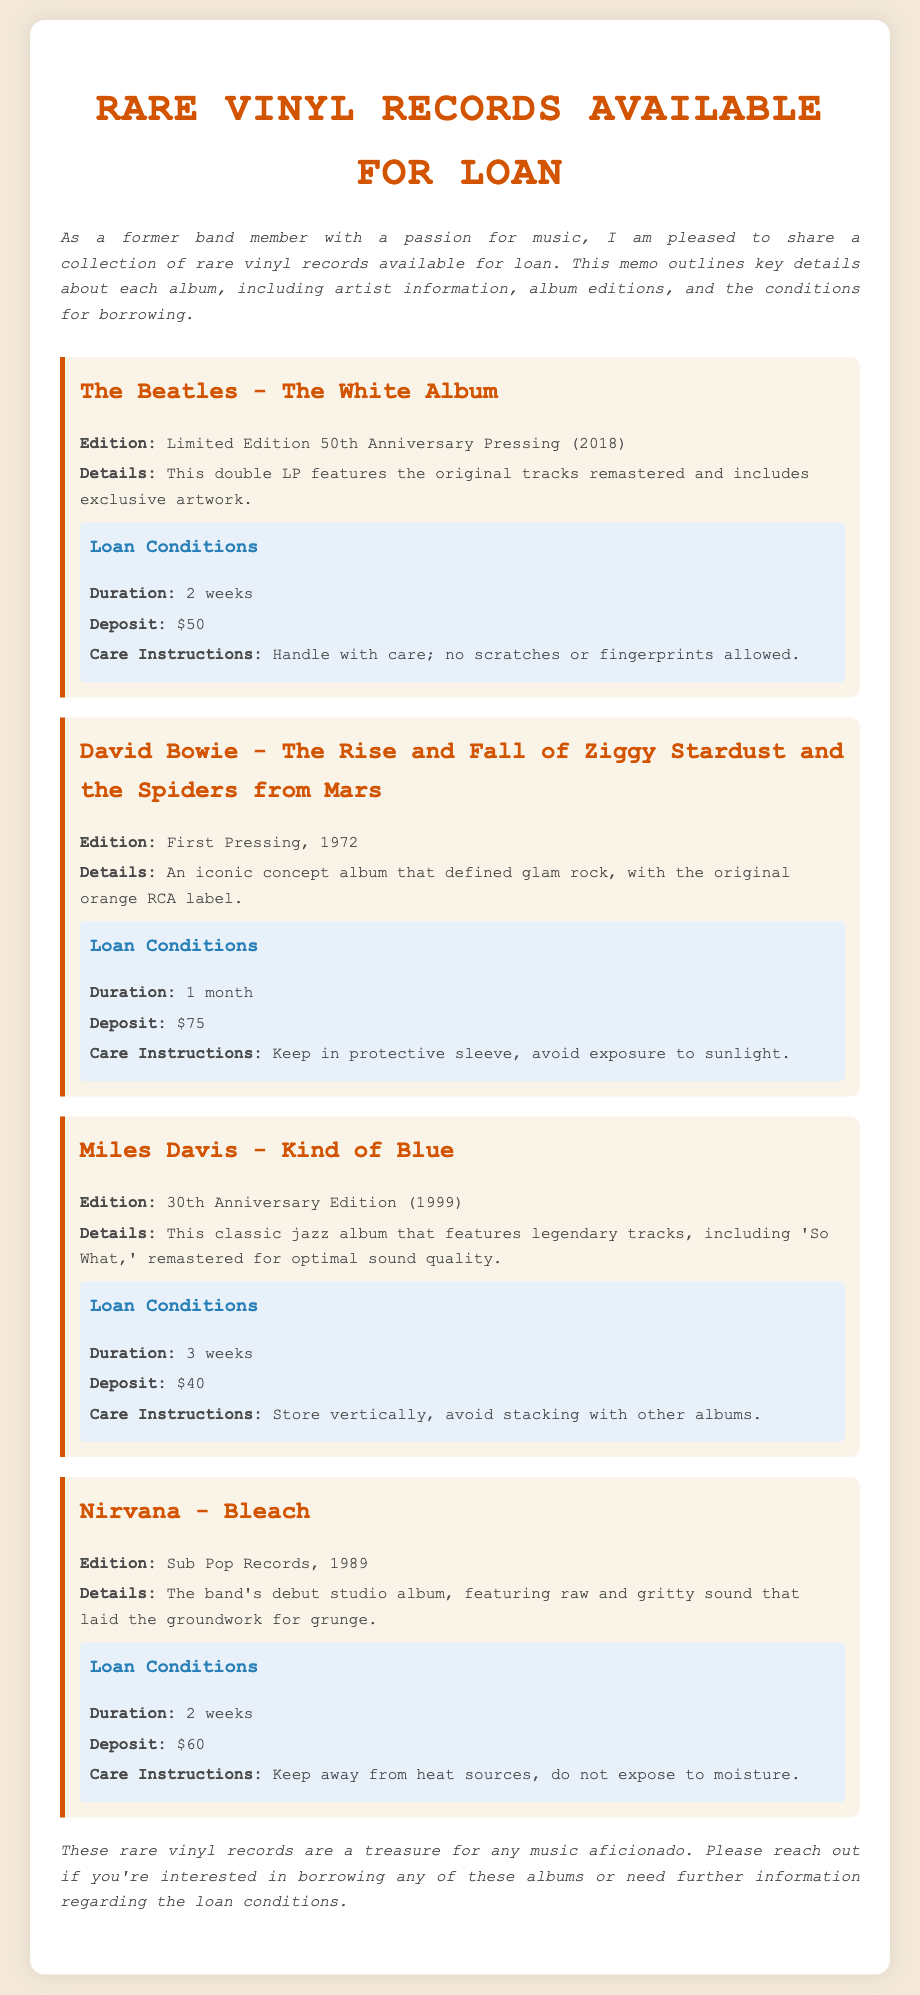What is the edition of The Beatles album? The edition of The Beatles album is specifically stated in the document and described as a Limited Edition 50th Anniversary Pressing (2018).
Answer: Limited Edition 50th Anniversary Pressing (2018) What is the deposit amount for David Bowie's album? The document outlines the deposit amount required for David Bowie's album under loan conditions, which is $75.
Answer: $75 How long can I borrow Miles Davis's album? The document specifies the loan duration for Miles Davis's album, which is 3 weeks.
Answer: 3 weeks What is the care instruction for Nirvana's Bleach? The care instructions for Nirvana's Bleach are specified in the loan conditions, stating to keep it away from heat sources and do not expose it to moisture.
Answer: Keep away from heat sources, do not expose to moisture Which album edition is the first pressing? The question refers to the specific edition mentioned for David Bowie's album, which is explicitly stated as the First Pressing, 1972.
Answer: First Pressing, 1972 What is the loan duration for The Beatles album? The loan duration for The Beatles album is mentioned under its respective loan conditions, which is 2 weeks.
Answer: 2 weeks Which artist has a vinyl with a 30th Anniversary Edition? This question involves reasoning over multiple sections of the document to identify the artist associated with that specific edition mentioned, which is Miles Davis.
Answer: Miles Davis What must be avoided when handling David Bowie's record? The document provides care instructions for handling David Bowie's record, indicating that exposure to sunlight should be avoided.
Answer: Avoid exposure to sunlight 